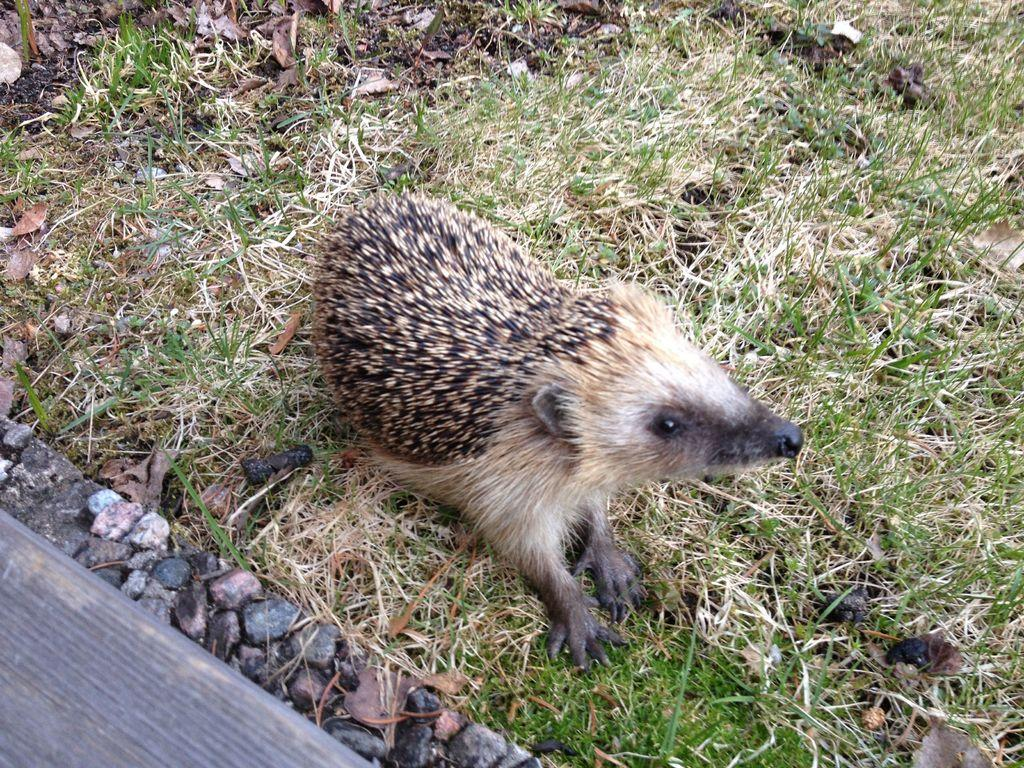What is the main subject on the ground in the image? There is an animal on the ground in the image. What type of vegetation is present on the ground? There is grass on the ground in the image. What can be seen near the animal and grass? There is a side wall with stones near the animal and grass. What type of apparel is the animal wearing in the image? There is no apparel visible on the animal in the image. 